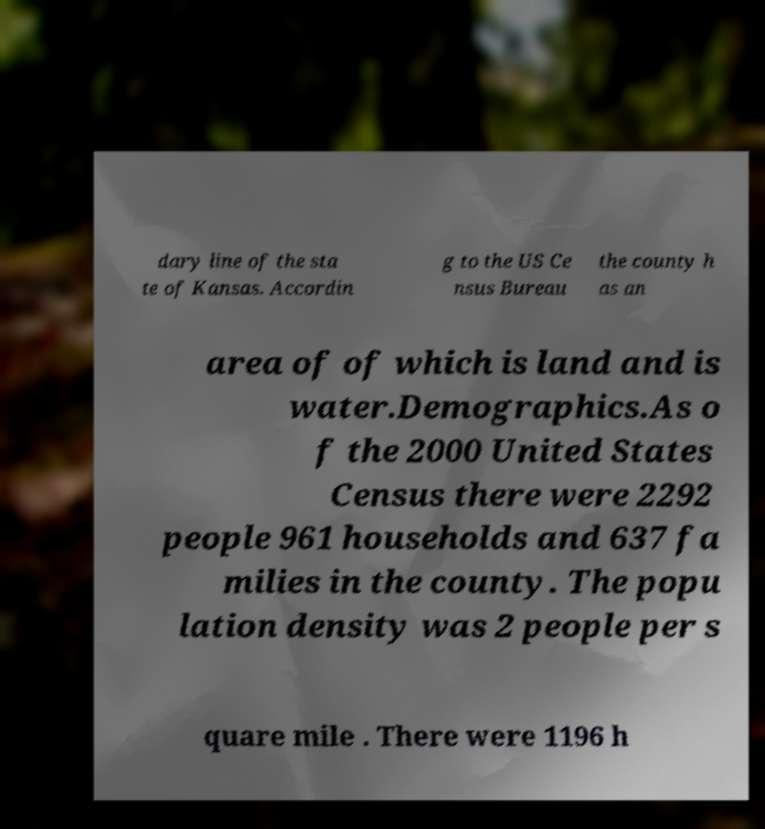Please identify and transcribe the text found in this image. dary line of the sta te of Kansas. Accordin g to the US Ce nsus Bureau the county h as an area of of which is land and is water.Demographics.As o f the 2000 United States Census there were 2292 people 961 households and 637 fa milies in the county. The popu lation density was 2 people per s quare mile . There were 1196 h 